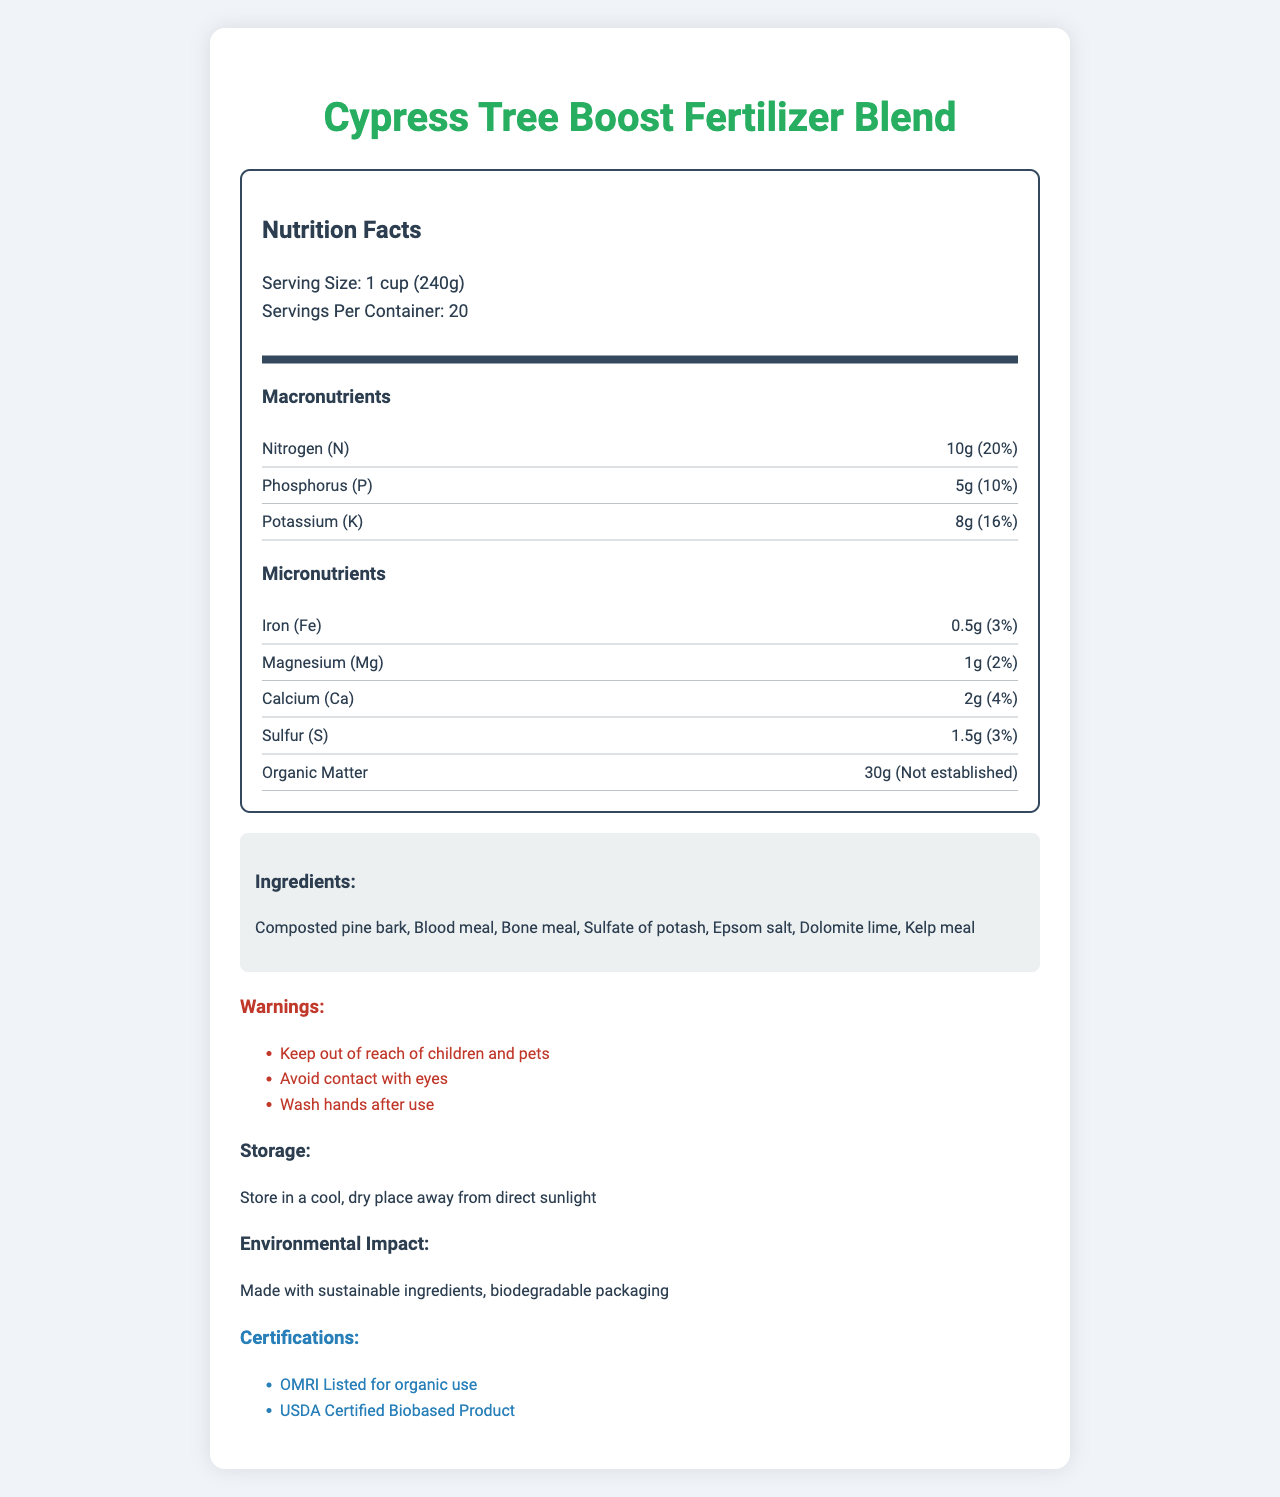what is the product name? The product name is prominently displayed in the title and heading of the document.
Answer: Cypress Tree Boost Fertilizer Blend what is the serving size? The serving size is specified below the Nutrition Facts header in the serving information section.
Answer: 1 cup (240g) how many servings are in the container? The number of servings per container is listed alongside the serving size in the serving information section.
Answer: 20 what is the pH level of the fertilizer blend? The pH level is mentioned in the data provided and can be seen in the application instructions section.
Answer: 6.5 name one ingredient in this fertilizer blend. One of the ingredients, compoted pine bark, is listed in the ingredients section.
Answer: Composted pine bark how often should the fertilizer be applied? The application frequency is specified in the application instructions section.
Answer: Monthly during growing season which nutrient has the highest amount per serving, Nitrogen (N), Phosphorus (P), or Potassium (K)? A. Nitrogen (N) B. Phosphorus (P) C. Potassium (K) Nitrogen has 10g per serving, Phosphorus has 5g per serving, and Potassium has 8g per serving. Nitrogen has the highest amount.
Answer: A. Nitrogen (N) which of the following certifications is mentioned? A. OMRI Listed B. Non-GMO Project Verified C. Fair Trade Certified The document lists OMRI Listed for organic use and USDA Certified Biobased Product as the certifications.
Answer: A. OMRI Listed does the fertilizer contain any magnesium? Magnesium (Mg) is listed under micronutrients with an amount of 1g.
Answer: Yes is this fertilizer certified for organic use? The document states that it is OMRI Listed for organic use.
Answer: Yes summarize the main information of the document. This document provides a comprehensive overview of the fertilizer blend, including its nutritional content, application guidelines, safe handling, and environmental impact, along with the certifications it has received.
Answer: The document describes the Cypress Tree Boost Fertilizer Blend, detailing its serving size, number of servings, macronutrients, micronutrients, pH level, application instructions, ingredients, warnings, storage instructions, environmental impact, and certifications. what is the exact daily value percentage of calcium in the fertilizer blend? The daily value percentage of calcium is listed under micronutrients as 4%.
Answer: 4% for how long can this fertilizer be stored? The document mentions to store in a cool, dry place away from direct sunlight but does not specify the duration for storage.
Answer: Not specified how much organic matter is present per serving? The amount of organic matter per serving is stated in the nutrients section.
Answer: 30g are there any warnings associated with this fertilizer? The document lists several warnings, including keeping it out of reach of children and pets, avoiding contact with eyes, and washing hands after use.
Answer: Yes what percentage of the daily value of sulfur does one serving of the fertilizer provide? The daily value percentage for sulfur is listed under micronutrients as 3%.
Answer: 3% how sustainable is the product packaging? The document mentions that the product is made with biodegradable packaging.
Answer: Biodegradable packaging what is the main listed application frequency of this fertilizer? The application instructions specify to apply monthly during the growing season.
Answer: Monthly 